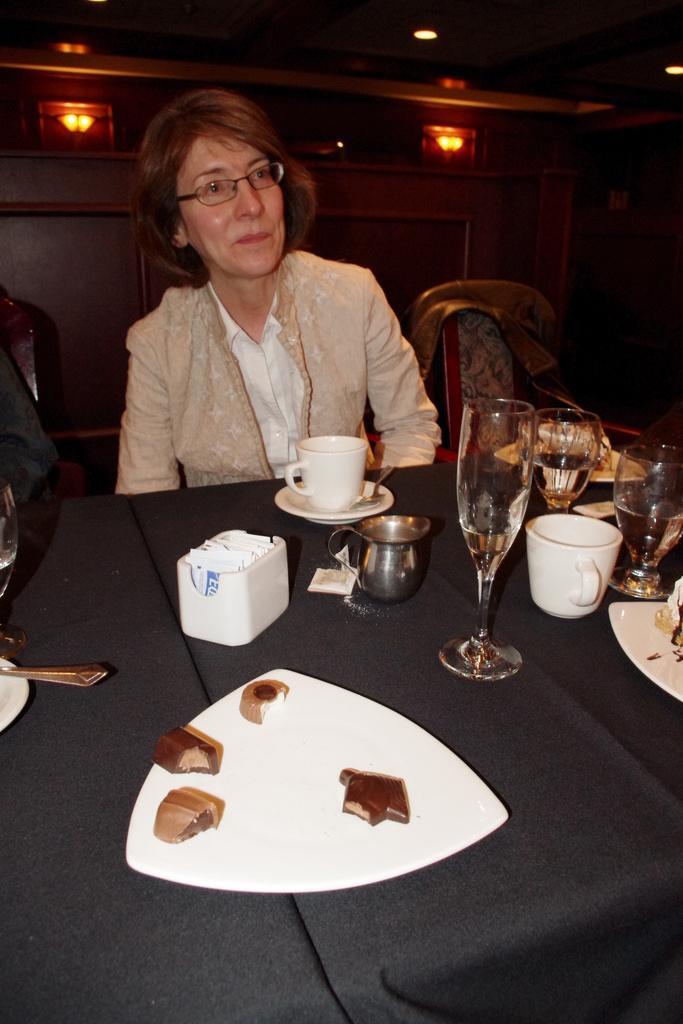Please provide a concise description of this image. In this image i can see a woman sit in front of the table ,on the table i can see a cups and glasses and plates kept on the table. 